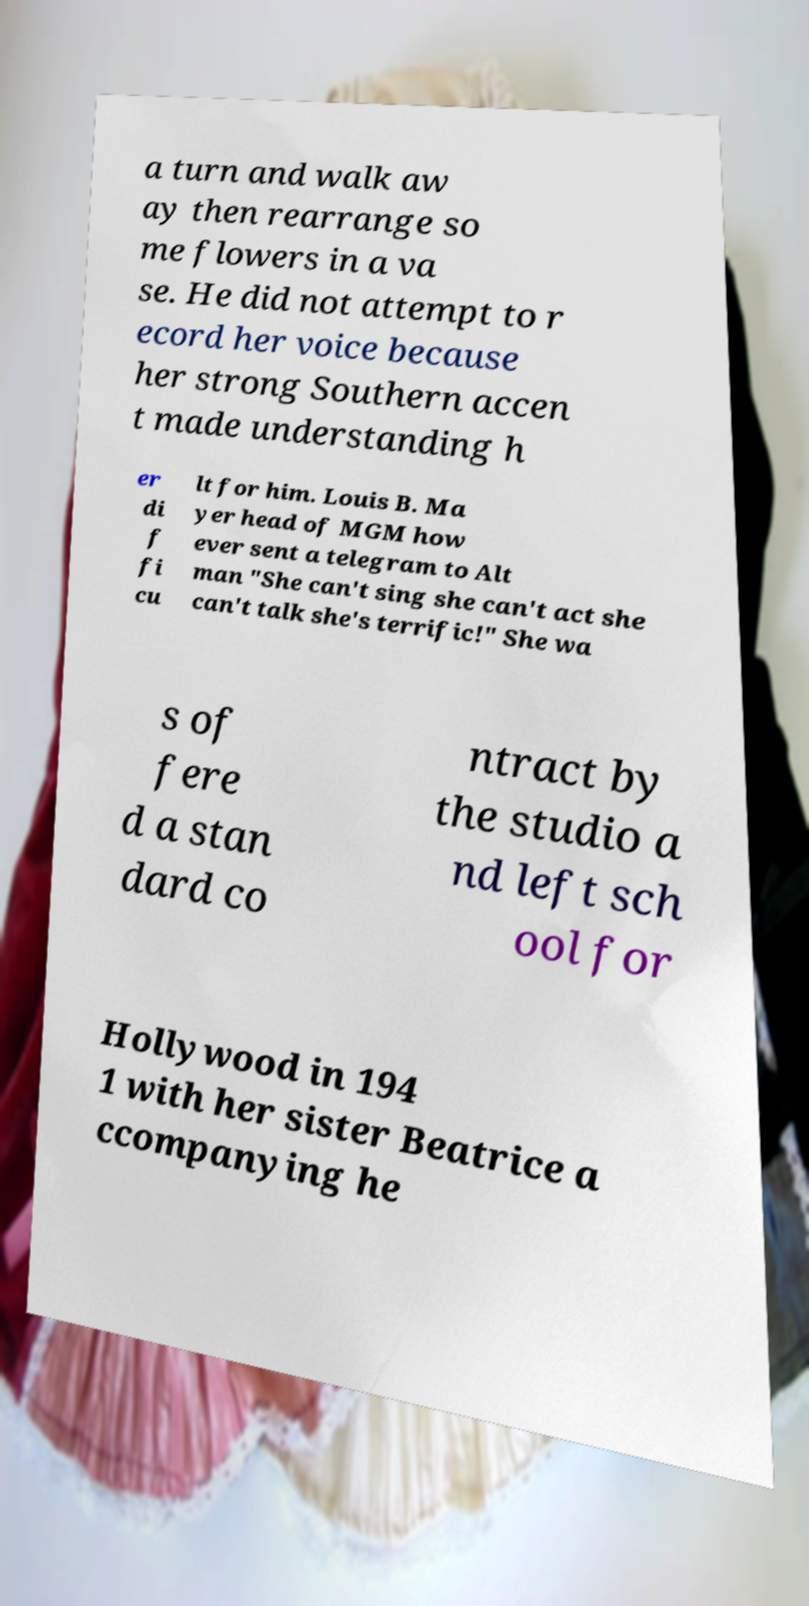Please read and relay the text visible in this image. What does it say? a turn and walk aw ay then rearrange so me flowers in a va se. He did not attempt to r ecord her voice because her strong Southern accen t made understanding h er di f fi cu lt for him. Louis B. Ma yer head of MGM how ever sent a telegram to Alt man "She can't sing she can't act she can't talk she's terrific!" She wa s of fere d a stan dard co ntract by the studio a nd left sch ool for Hollywood in 194 1 with her sister Beatrice a ccompanying he 